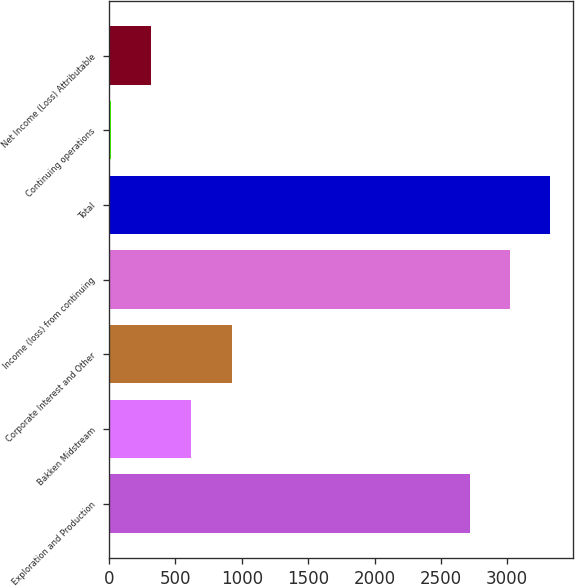Convert chart to OTSL. <chart><loc_0><loc_0><loc_500><loc_500><bar_chart><fcel>Exploration and Production<fcel>Bakken Midstream<fcel>Corporate Interest and Other<fcel>Income (loss) from continuing<fcel>Total<fcel>Continuing operations<fcel>Net Income (Loss) Attributable<nl><fcel>2717<fcel>619.69<fcel>924.23<fcel>3021.54<fcel>3326.08<fcel>10.61<fcel>315.15<nl></chart> 